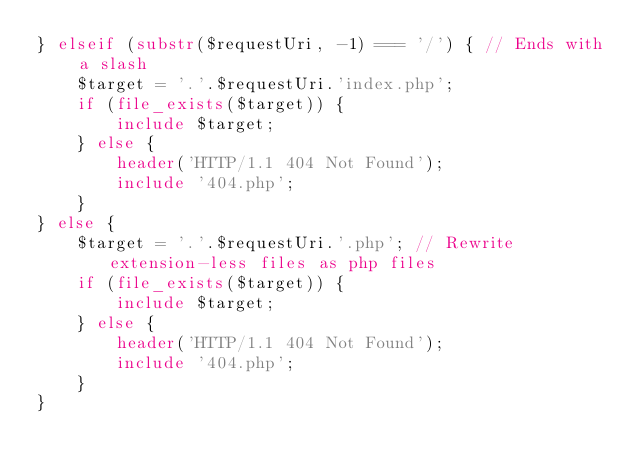<code> <loc_0><loc_0><loc_500><loc_500><_PHP_>} elseif (substr($requestUri, -1) === '/') { // Ends with a slash
    $target = '.'.$requestUri.'index.php';
    if (file_exists($target)) {
        include $target;
    } else {
        header('HTTP/1.1 404 Not Found');
        include '404.php';
    }
} else {
    $target = '.'.$requestUri.'.php'; // Rewrite extension-less files as php files
    if (file_exists($target)) {
        include $target;
    } else {
        header('HTTP/1.1 404 Not Found');
        include '404.php';
    }
}
</code> 